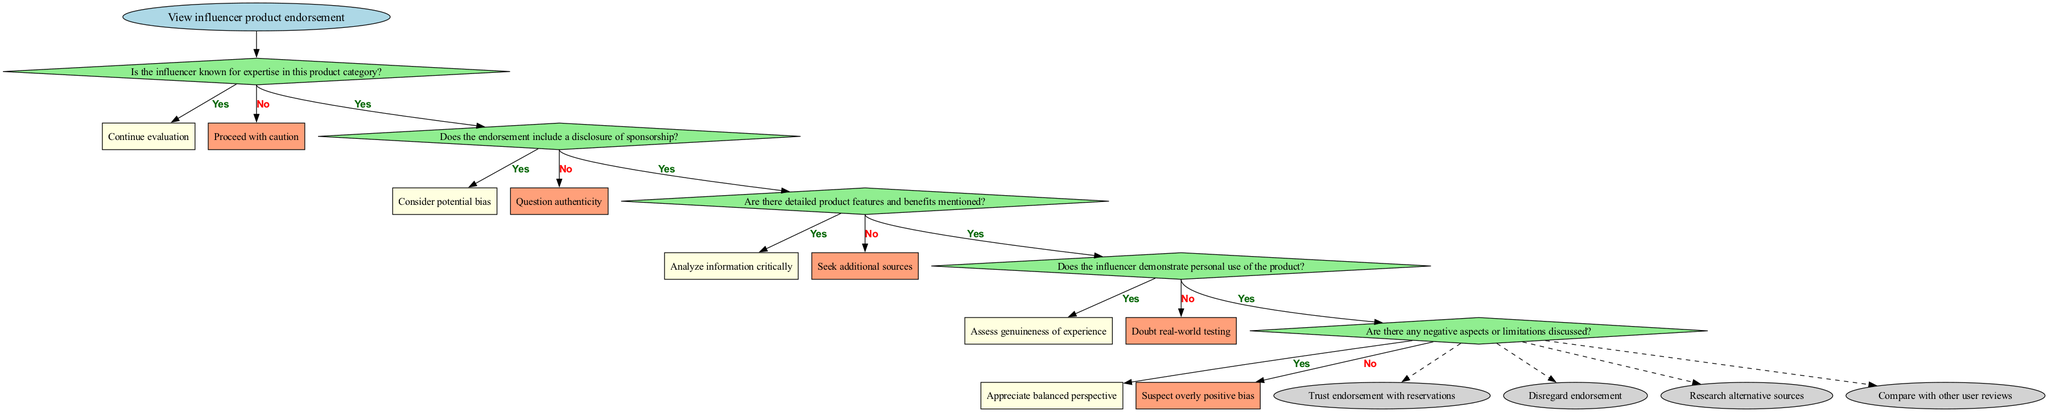What is the starting point of the flowchart? The starting point, indicated by the 'start' node, is "View influencer product endorsement".
Answer: View influencer product endorsement How many decision nodes are there in the flow chart? There are five decision nodes, each represented as a diamond shape within the flowchart.
Answer: 5 What happens if the answer to "Is the influencer known for expertise in this product category?" is yes? If the answer is yes, the flow continues to the next decision point for further evaluation.
Answer: Continue evaluation If the answer to "Does the endorsement include a disclosure of sponsorship?" is no, what is the next step? If the answer is no, the flowchart suggests questioning the authenticity of the endorsement before proceeding.
Answer: Question authenticity What endpoint is reached if there are no negative aspects or limitations discussed? If there are no negative aspects discussed, the flowchart indicates to suspect an overly positive bias and would lead to disregarding the endorsement.
Answer: Disregard endorsement Which decision node leads to the assessment of the genuineness of experience? The decision node focused on whether "Does the influencer demonstrate personal use of the product?" leads to assessing the genuineness of experience if answered yes.
Answer: Does the influencer demonstrate personal use of the product? What is indicated by the endpoint titled "Research alternative sources"? This endpoint suggests that if there is a lack of detailed product features and benefits mentioned, the next action is to look for alternative sources of information.
Answer: Research alternative sources What color are the decision nodes in the diagram? The decision nodes are filled with light green color, visually distinguishing them from other node types.
Answer: Light green If the endorsement considers potential bias, what is the next decision to evaluate? If potential bias is considered, it directs the evaluation to whether there are detailed product features and benefits mentioned next.
Answer: Are there detailed product features and benefits mentioned? 